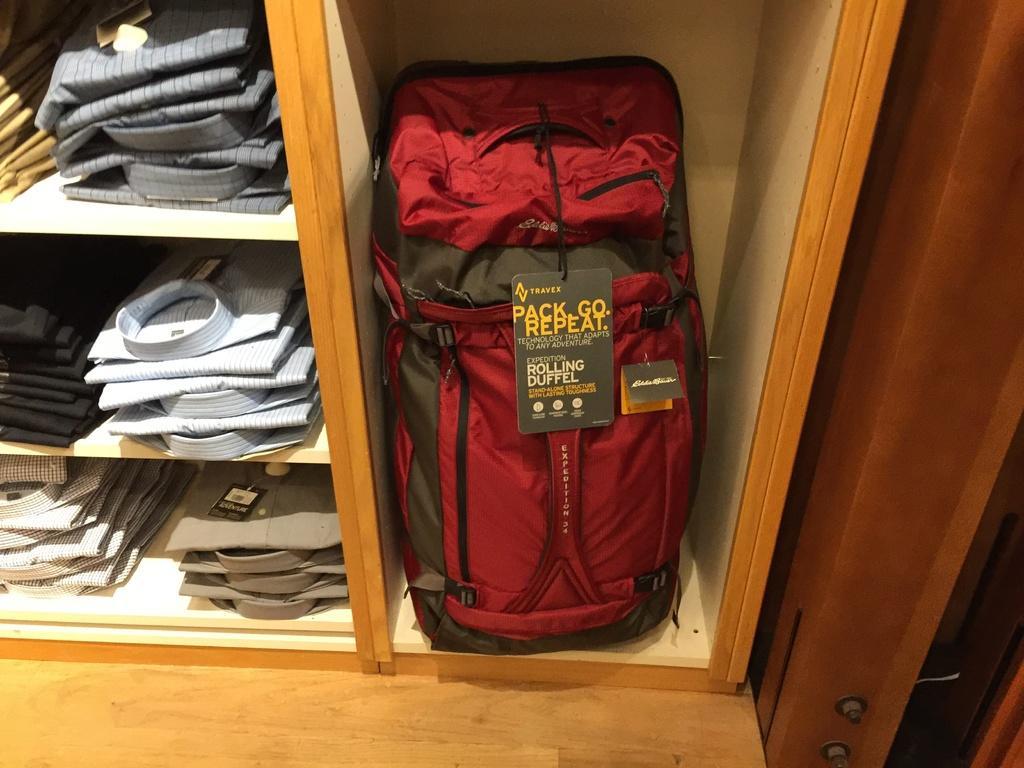Can you describe this image briefly? In this image on the right side there is one luggage, and on the left side there are some shirts are there. 